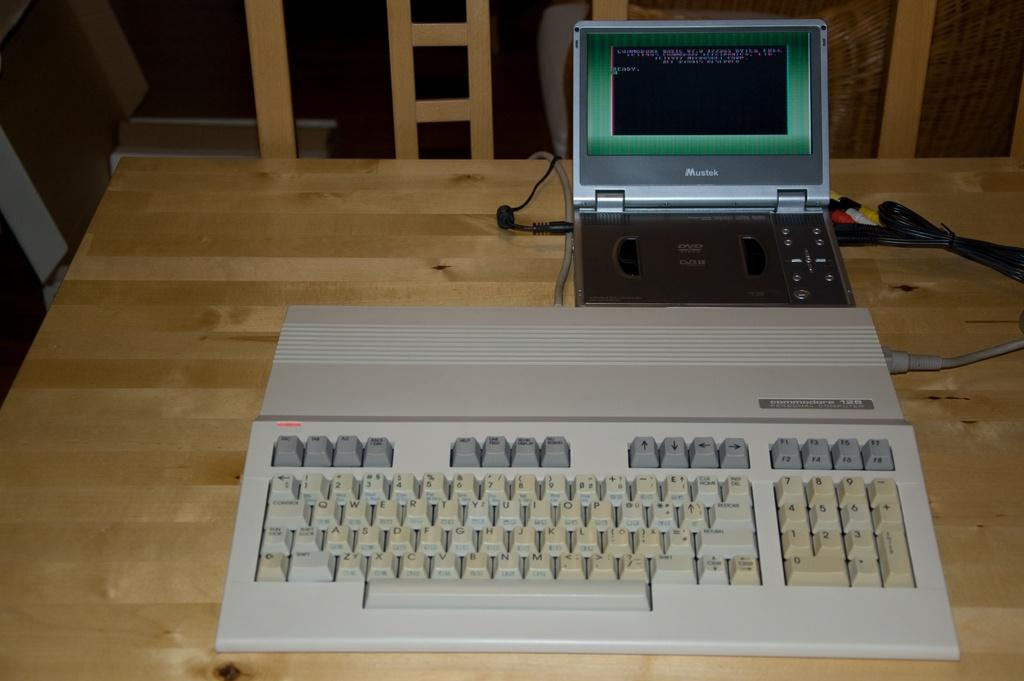<image>
Write a terse but informative summary of the picture. An old Commodore 128 computer is on a wooden table with a Mustek device connected to it. 